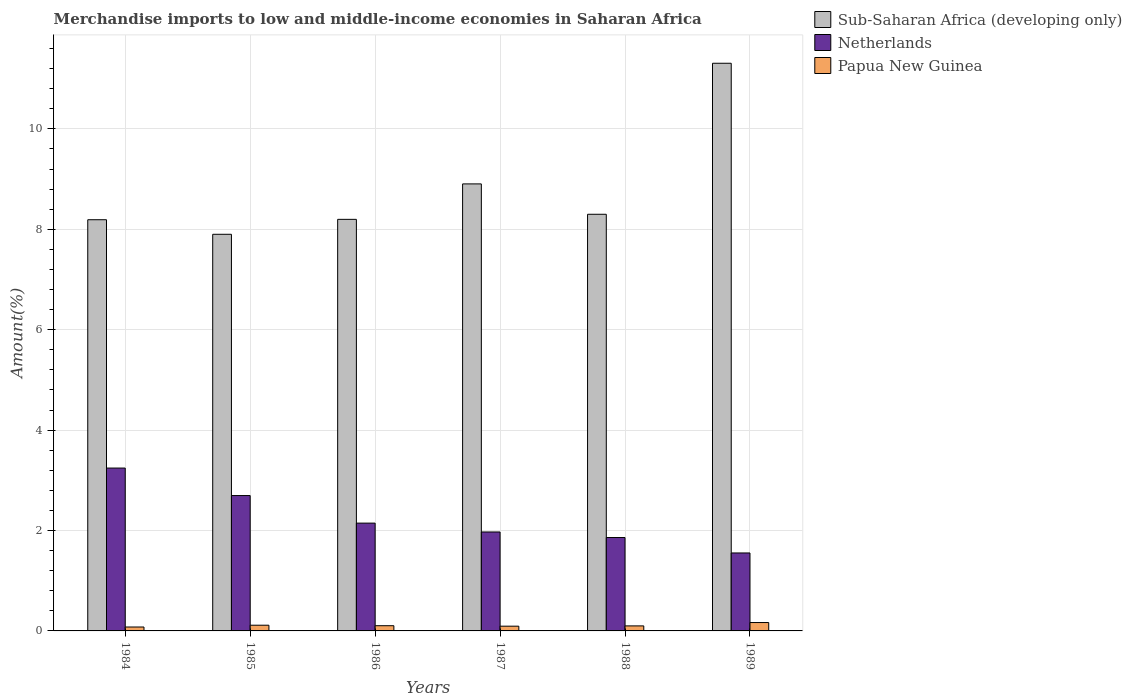How many different coloured bars are there?
Provide a succinct answer. 3. Are the number of bars per tick equal to the number of legend labels?
Keep it short and to the point. Yes. Are the number of bars on each tick of the X-axis equal?
Ensure brevity in your answer.  Yes. How many bars are there on the 2nd tick from the left?
Provide a succinct answer. 3. What is the label of the 5th group of bars from the left?
Your response must be concise. 1988. What is the percentage of amount earned from merchandise imports in Netherlands in 1987?
Make the answer very short. 1.97. Across all years, what is the maximum percentage of amount earned from merchandise imports in Netherlands?
Provide a short and direct response. 3.24. Across all years, what is the minimum percentage of amount earned from merchandise imports in Papua New Guinea?
Make the answer very short. 0.08. In which year was the percentage of amount earned from merchandise imports in Sub-Saharan Africa (developing only) maximum?
Ensure brevity in your answer.  1989. In which year was the percentage of amount earned from merchandise imports in Sub-Saharan Africa (developing only) minimum?
Keep it short and to the point. 1985. What is the total percentage of amount earned from merchandise imports in Netherlands in the graph?
Keep it short and to the point. 13.47. What is the difference between the percentage of amount earned from merchandise imports in Sub-Saharan Africa (developing only) in 1984 and that in 1986?
Give a very brief answer. -0.01. What is the difference between the percentage of amount earned from merchandise imports in Netherlands in 1988 and the percentage of amount earned from merchandise imports in Sub-Saharan Africa (developing only) in 1989?
Your answer should be compact. -9.45. What is the average percentage of amount earned from merchandise imports in Sub-Saharan Africa (developing only) per year?
Provide a short and direct response. 8.8. In the year 1987, what is the difference between the percentage of amount earned from merchandise imports in Papua New Guinea and percentage of amount earned from merchandise imports in Netherlands?
Your response must be concise. -1.88. What is the ratio of the percentage of amount earned from merchandise imports in Netherlands in 1987 to that in 1989?
Give a very brief answer. 1.27. What is the difference between the highest and the second highest percentage of amount earned from merchandise imports in Netherlands?
Offer a very short reply. 0.55. What is the difference between the highest and the lowest percentage of amount earned from merchandise imports in Sub-Saharan Africa (developing only)?
Make the answer very short. 3.41. What does the 3rd bar from the left in 1989 represents?
Your answer should be compact. Papua New Guinea. What does the 2nd bar from the right in 1988 represents?
Ensure brevity in your answer.  Netherlands. Is it the case that in every year, the sum of the percentage of amount earned from merchandise imports in Papua New Guinea and percentage of amount earned from merchandise imports in Sub-Saharan Africa (developing only) is greater than the percentage of amount earned from merchandise imports in Netherlands?
Make the answer very short. Yes. How many bars are there?
Your answer should be compact. 18. Are all the bars in the graph horizontal?
Keep it short and to the point. No. What is the difference between two consecutive major ticks on the Y-axis?
Your response must be concise. 2. Are the values on the major ticks of Y-axis written in scientific E-notation?
Give a very brief answer. No. Does the graph contain any zero values?
Ensure brevity in your answer.  No. Does the graph contain grids?
Ensure brevity in your answer.  Yes. Where does the legend appear in the graph?
Your answer should be compact. Top right. How many legend labels are there?
Your response must be concise. 3. What is the title of the graph?
Provide a succinct answer. Merchandise imports to low and middle-income economies in Saharan Africa. What is the label or title of the Y-axis?
Provide a succinct answer. Amount(%). What is the Amount(%) in Sub-Saharan Africa (developing only) in 1984?
Your answer should be compact. 8.19. What is the Amount(%) in Netherlands in 1984?
Provide a succinct answer. 3.24. What is the Amount(%) in Papua New Guinea in 1984?
Ensure brevity in your answer.  0.08. What is the Amount(%) in Sub-Saharan Africa (developing only) in 1985?
Your answer should be compact. 7.9. What is the Amount(%) of Netherlands in 1985?
Provide a succinct answer. 2.7. What is the Amount(%) of Papua New Guinea in 1985?
Ensure brevity in your answer.  0.11. What is the Amount(%) of Sub-Saharan Africa (developing only) in 1986?
Make the answer very short. 8.2. What is the Amount(%) in Netherlands in 1986?
Offer a terse response. 2.15. What is the Amount(%) in Papua New Guinea in 1986?
Your answer should be compact. 0.1. What is the Amount(%) of Sub-Saharan Africa (developing only) in 1987?
Your response must be concise. 8.9. What is the Amount(%) in Netherlands in 1987?
Your answer should be compact. 1.97. What is the Amount(%) of Papua New Guinea in 1987?
Your response must be concise. 0.09. What is the Amount(%) of Sub-Saharan Africa (developing only) in 1988?
Give a very brief answer. 8.3. What is the Amount(%) in Netherlands in 1988?
Keep it short and to the point. 1.86. What is the Amount(%) in Papua New Guinea in 1988?
Offer a very short reply. 0.1. What is the Amount(%) in Sub-Saharan Africa (developing only) in 1989?
Make the answer very short. 11.31. What is the Amount(%) in Netherlands in 1989?
Ensure brevity in your answer.  1.55. What is the Amount(%) in Papua New Guinea in 1989?
Give a very brief answer. 0.17. Across all years, what is the maximum Amount(%) of Sub-Saharan Africa (developing only)?
Provide a succinct answer. 11.31. Across all years, what is the maximum Amount(%) in Netherlands?
Offer a terse response. 3.24. Across all years, what is the maximum Amount(%) of Papua New Guinea?
Your answer should be compact. 0.17. Across all years, what is the minimum Amount(%) in Sub-Saharan Africa (developing only)?
Keep it short and to the point. 7.9. Across all years, what is the minimum Amount(%) in Netherlands?
Keep it short and to the point. 1.55. Across all years, what is the minimum Amount(%) of Papua New Guinea?
Your response must be concise. 0.08. What is the total Amount(%) of Sub-Saharan Africa (developing only) in the graph?
Ensure brevity in your answer.  52.8. What is the total Amount(%) of Netherlands in the graph?
Make the answer very short. 13.47. What is the total Amount(%) in Papua New Guinea in the graph?
Your answer should be compact. 0.66. What is the difference between the Amount(%) in Sub-Saharan Africa (developing only) in 1984 and that in 1985?
Offer a very short reply. 0.29. What is the difference between the Amount(%) of Netherlands in 1984 and that in 1985?
Keep it short and to the point. 0.55. What is the difference between the Amount(%) of Papua New Guinea in 1984 and that in 1985?
Offer a very short reply. -0.04. What is the difference between the Amount(%) of Sub-Saharan Africa (developing only) in 1984 and that in 1986?
Your answer should be very brief. -0.01. What is the difference between the Amount(%) in Netherlands in 1984 and that in 1986?
Your answer should be very brief. 1.1. What is the difference between the Amount(%) of Papua New Guinea in 1984 and that in 1986?
Give a very brief answer. -0.03. What is the difference between the Amount(%) in Sub-Saharan Africa (developing only) in 1984 and that in 1987?
Your answer should be compact. -0.71. What is the difference between the Amount(%) of Netherlands in 1984 and that in 1987?
Your response must be concise. 1.27. What is the difference between the Amount(%) of Papua New Guinea in 1984 and that in 1987?
Provide a succinct answer. -0.02. What is the difference between the Amount(%) of Sub-Saharan Africa (developing only) in 1984 and that in 1988?
Offer a very short reply. -0.11. What is the difference between the Amount(%) in Netherlands in 1984 and that in 1988?
Your answer should be compact. 1.38. What is the difference between the Amount(%) of Papua New Guinea in 1984 and that in 1988?
Provide a succinct answer. -0.02. What is the difference between the Amount(%) in Sub-Saharan Africa (developing only) in 1984 and that in 1989?
Provide a succinct answer. -3.12. What is the difference between the Amount(%) of Netherlands in 1984 and that in 1989?
Make the answer very short. 1.69. What is the difference between the Amount(%) in Papua New Guinea in 1984 and that in 1989?
Your answer should be very brief. -0.09. What is the difference between the Amount(%) in Sub-Saharan Africa (developing only) in 1985 and that in 1986?
Keep it short and to the point. -0.3. What is the difference between the Amount(%) of Netherlands in 1985 and that in 1986?
Your response must be concise. 0.55. What is the difference between the Amount(%) in Sub-Saharan Africa (developing only) in 1985 and that in 1987?
Give a very brief answer. -1. What is the difference between the Amount(%) in Netherlands in 1985 and that in 1987?
Offer a terse response. 0.73. What is the difference between the Amount(%) of Papua New Guinea in 1985 and that in 1987?
Offer a very short reply. 0.02. What is the difference between the Amount(%) in Sub-Saharan Africa (developing only) in 1985 and that in 1988?
Make the answer very short. -0.4. What is the difference between the Amount(%) of Netherlands in 1985 and that in 1988?
Ensure brevity in your answer.  0.84. What is the difference between the Amount(%) in Papua New Guinea in 1985 and that in 1988?
Keep it short and to the point. 0.01. What is the difference between the Amount(%) of Sub-Saharan Africa (developing only) in 1985 and that in 1989?
Offer a terse response. -3.41. What is the difference between the Amount(%) of Netherlands in 1985 and that in 1989?
Make the answer very short. 1.14. What is the difference between the Amount(%) of Papua New Guinea in 1985 and that in 1989?
Make the answer very short. -0.05. What is the difference between the Amount(%) of Sub-Saharan Africa (developing only) in 1986 and that in 1987?
Keep it short and to the point. -0.71. What is the difference between the Amount(%) of Netherlands in 1986 and that in 1987?
Offer a very short reply. 0.18. What is the difference between the Amount(%) of Papua New Guinea in 1986 and that in 1987?
Offer a terse response. 0.01. What is the difference between the Amount(%) of Sub-Saharan Africa (developing only) in 1986 and that in 1988?
Make the answer very short. -0.1. What is the difference between the Amount(%) in Netherlands in 1986 and that in 1988?
Give a very brief answer. 0.29. What is the difference between the Amount(%) in Papua New Guinea in 1986 and that in 1988?
Your response must be concise. 0. What is the difference between the Amount(%) in Sub-Saharan Africa (developing only) in 1986 and that in 1989?
Make the answer very short. -3.11. What is the difference between the Amount(%) of Netherlands in 1986 and that in 1989?
Provide a short and direct response. 0.59. What is the difference between the Amount(%) in Papua New Guinea in 1986 and that in 1989?
Give a very brief answer. -0.06. What is the difference between the Amount(%) of Sub-Saharan Africa (developing only) in 1987 and that in 1988?
Offer a terse response. 0.6. What is the difference between the Amount(%) of Netherlands in 1987 and that in 1988?
Your answer should be very brief. 0.11. What is the difference between the Amount(%) in Papua New Guinea in 1987 and that in 1988?
Your answer should be compact. -0.01. What is the difference between the Amount(%) of Sub-Saharan Africa (developing only) in 1987 and that in 1989?
Offer a very short reply. -2.4. What is the difference between the Amount(%) in Netherlands in 1987 and that in 1989?
Ensure brevity in your answer.  0.42. What is the difference between the Amount(%) of Papua New Guinea in 1987 and that in 1989?
Give a very brief answer. -0.07. What is the difference between the Amount(%) of Sub-Saharan Africa (developing only) in 1988 and that in 1989?
Keep it short and to the point. -3.01. What is the difference between the Amount(%) of Netherlands in 1988 and that in 1989?
Make the answer very short. 0.31. What is the difference between the Amount(%) of Papua New Guinea in 1988 and that in 1989?
Ensure brevity in your answer.  -0.07. What is the difference between the Amount(%) in Sub-Saharan Africa (developing only) in 1984 and the Amount(%) in Netherlands in 1985?
Offer a terse response. 5.49. What is the difference between the Amount(%) in Sub-Saharan Africa (developing only) in 1984 and the Amount(%) in Papua New Guinea in 1985?
Offer a terse response. 8.08. What is the difference between the Amount(%) in Netherlands in 1984 and the Amount(%) in Papua New Guinea in 1985?
Provide a short and direct response. 3.13. What is the difference between the Amount(%) of Sub-Saharan Africa (developing only) in 1984 and the Amount(%) of Netherlands in 1986?
Provide a succinct answer. 6.04. What is the difference between the Amount(%) in Sub-Saharan Africa (developing only) in 1984 and the Amount(%) in Papua New Guinea in 1986?
Keep it short and to the point. 8.09. What is the difference between the Amount(%) in Netherlands in 1984 and the Amount(%) in Papua New Guinea in 1986?
Your response must be concise. 3.14. What is the difference between the Amount(%) of Sub-Saharan Africa (developing only) in 1984 and the Amount(%) of Netherlands in 1987?
Give a very brief answer. 6.22. What is the difference between the Amount(%) in Sub-Saharan Africa (developing only) in 1984 and the Amount(%) in Papua New Guinea in 1987?
Offer a very short reply. 8.1. What is the difference between the Amount(%) of Netherlands in 1984 and the Amount(%) of Papua New Guinea in 1987?
Give a very brief answer. 3.15. What is the difference between the Amount(%) of Sub-Saharan Africa (developing only) in 1984 and the Amount(%) of Netherlands in 1988?
Keep it short and to the point. 6.33. What is the difference between the Amount(%) of Sub-Saharan Africa (developing only) in 1984 and the Amount(%) of Papua New Guinea in 1988?
Offer a terse response. 8.09. What is the difference between the Amount(%) of Netherlands in 1984 and the Amount(%) of Papua New Guinea in 1988?
Keep it short and to the point. 3.14. What is the difference between the Amount(%) in Sub-Saharan Africa (developing only) in 1984 and the Amount(%) in Netherlands in 1989?
Provide a short and direct response. 6.64. What is the difference between the Amount(%) of Sub-Saharan Africa (developing only) in 1984 and the Amount(%) of Papua New Guinea in 1989?
Give a very brief answer. 8.02. What is the difference between the Amount(%) of Netherlands in 1984 and the Amount(%) of Papua New Guinea in 1989?
Keep it short and to the point. 3.08. What is the difference between the Amount(%) in Sub-Saharan Africa (developing only) in 1985 and the Amount(%) in Netherlands in 1986?
Your answer should be very brief. 5.75. What is the difference between the Amount(%) in Sub-Saharan Africa (developing only) in 1985 and the Amount(%) in Papua New Guinea in 1986?
Your answer should be very brief. 7.8. What is the difference between the Amount(%) in Netherlands in 1985 and the Amount(%) in Papua New Guinea in 1986?
Offer a very short reply. 2.59. What is the difference between the Amount(%) in Sub-Saharan Africa (developing only) in 1985 and the Amount(%) in Netherlands in 1987?
Your response must be concise. 5.93. What is the difference between the Amount(%) of Sub-Saharan Africa (developing only) in 1985 and the Amount(%) of Papua New Guinea in 1987?
Provide a short and direct response. 7.81. What is the difference between the Amount(%) in Netherlands in 1985 and the Amount(%) in Papua New Guinea in 1987?
Offer a very short reply. 2.6. What is the difference between the Amount(%) of Sub-Saharan Africa (developing only) in 1985 and the Amount(%) of Netherlands in 1988?
Your response must be concise. 6.04. What is the difference between the Amount(%) of Sub-Saharan Africa (developing only) in 1985 and the Amount(%) of Papua New Guinea in 1988?
Give a very brief answer. 7.8. What is the difference between the Amount(%) in Netherlands in 1985 and the Amount(%) in Papua New Guinea in 1988?
Your response must be concise. 2.6. What is the difference between the Amount(%) of Sub-Saharan Africa (developing only) in 1985 and the Amount(%) of Netherlands in 1989?
Give a very brief answer. 6.35. What is the difference between the Amount(%) in Sub-Saharan Africa (developing only) in 1985 and the Amount(%) in Papua New Guinea in 1989?
Keep it short and to the point. 7.73. What is the difference between the Amount(%) of Netherlands in 1985 and the Amount(%) of Papua New Guinea in 1989?
Your response must be concise. 2.53. What is the difference between the Amount(%) in Sub-Saharan Africa (developing only) in 1986 and the Amount(%) in Netherlands in 1987?
Make the answer very short. 6.23. What is the difference between the Amount(%) of Sub-Saharan Africa (developing only) in 1986 and the Amount(%) of Papua New Guinea in 1987?
Offer a very short reply. 8.1. What is the difference between the Amount(%) in Netherlands in 1986 and the Amount(%) in Papua New Guinea in 1987?
Your answer should be very brief. 2.05. What is the difference between the Amount(%) in Sub-Saharan Africa (developing only) in 1986 and the Amount(%) in Netherlands in 1988?
Provide a succinct answer. 6.34. What is the difference between the Amount(%) in Sub-Saharan Africa (developing only) in 1986 and the Amount(%) in Papua New Guinea in 1988?
Your answer should be very brief. 8.1. What is the difference between the Amount(%) in Netherlands in 1986 and the Amount(%) in Papua New Guinea in 1988?
Make the answer very short. 2.05. What is the difference between the Amount(%) of Sub-Saharan Africa (developing only) in 1986 and the Amount(%) of Netherlands in 1989?
Offer a terse response. 6.65. What is the difference between the Amount(%) of Sub-Saharan Africa (developing only) in 1986 and the Amount(%) of Papua New Guinea in 1989?
Provide a short and direct response. 8.03. What is the difference between the Amount(%) of Netherlands in 1986 and the Amount(%) of Papua New Guinea in 1989?
Keep it short and to the point. 1.98. What is the difference between the Amount(%) in Sub-Saharan Africa (developing only) in 1987 and the Amount(%) in Netherlands in 1988?
Ensure brevity in your answer.  7.04. What is the difference between the Amount(%) in Sub-Saharan Africa (developing only) in 1987 and the Amount(%) in Papua New Guinea in 1988?
Ensure brevity in your answer.  8.8. What is the difference between the Amount(%) of Netherlands in 1987 and the Amount(%) of Papua New Guinea in 1988?
Give a very brief answer. 1.87. What is the difference between the Amount(%) in Sub-Saharan Africa (developing only) in 1987 and the Amount(%) in Netherlands in 1989?
Your response must be concise. 7.35. What is the difference between the Amount(%) in Sub-Saharan Africa (developing only) in 1987 and the Amount(%) in Papua New Guinea in 1989?
Provide a short and direct response. 8.74. What is the difference between the Amount(%) in Netherlands in 1987 and the Amount(%) in Papua New Guinea in 1989?
Give a very brief answer. 1.8. What is the difference between the Amount(%) in Sub-Saharan Africa (developing only) in 1988 and the Amount(%) in Netherlands in 1989?
Your answer should be very brief. 6.75. What is the difference between the Amount(%) of Sub-Saharan Africa (developing only) in 1988 and the Amount(%) of Papua New Guinea in 1989?
Provide a short and direct response. 8.13. What is the difference between the Amount(%) of Netherlands in 1988 and the Amount(%) of Papua New Guinea in 1989?
Provide a short and direct response. 1.69. What is the average Amount(%) of Sub-Saharan Africa (developing only) per year?
Keep it short and to the point. 8.8. What is the average Amount(%) in Netherlands per year?
Make the answer very short. 2.25. What is the average Amount(%) in Papua New Guinea per year?
Provide a short and direct response. 0.11. In the year 1984, what is the difference between the Amount(%) in Sub-Saharan Africa (developing only) and Amount(%) in Netherlands?
Your answer should be very brief. 4.95. In the year 1984, what is the difference between the Amount(%) of Sub-Saharan Africa (developing only) and Amount(%) of Papua New Guinea?
Provide a short and direct response. 8.11. In the year 1984, what is the difference between the Amount(%) of Netherlands and Amount(%) of Papua New Guinea?
Provide a short and direct response. 3.17. In the year 1985, what is the difference between the Amount(%) in Sub-Saharan Africa (developing only) and Amount(%) in Netherlands?
Offer a terse response. 5.2. In the year 1985, what is the difference between the Amount(%) of Sub-Saharan Africa (developing only) and Amount(%) of Papua New Guinea?
Your response must be concise. 7.79. In the year 1985, what is the difference between the Amount(%) in Netherlands and Amount(%) in Papua New Guinea?
Offer a terse response. 2.58. In the year 1986, what is the difference between the Amount(%) in Sub-Saharan Africa (developing only) and Amount(%) in Netherlands?
Your answer should be compact. 6.05. In the year 1986, what is the difference between the Amount(%) in Sub-Saharan Africa (developing only) and Amount(%) in Papua New Guinea?
Your answer should be compact. 8.09. In the year 1986, what is the difference between the Amount(%) in Netherlands and Amount(%) in Papua New Guinea?
Make the answer very short. 2.04. In the year 1987, what is the difference between the Amount(%) of Sub-Saharan Africa (developing only) and Amount(%) of Netherlands?
Ensure brevity in your answer.  6.93. In the year 1987, what is the difference between the Amount(%) in Sub-Saharan Africa (developing only) and Amount(%) in Papua New Guinea?
Offer a very short reply. 8.81. In the year 1987, what is the difference between the Amount(%) in Netherlands and Amount(%) in Papua New Guinea?
Make the answer very short. 1.88. In the year 1988, what is the difference between the Amount(%) of Sub-Saharan Africa (developing only) and Amount(%) of Netherlands?
Provide a short and direct response. 6.44. In the year 1988, what is the difference between the Amount(%) in Sub-Saharan Africa (developing only) and Amount(%) in Papua New Guinea?
Your answer should be very brief. 8.2. In the year 1988, what is the difference between the Amount(%) in Netherlands and Amount(%) in Papua New Guinea?
Your answer should be compact. 1.76. In the year 1989, what is the difference between the Amount(%) in Sub-Saharan Africa (developing only) and Amount(%) in Netherlands?
Provide a short and direct response. 9.75. In the year 1989, what is the difference between the Amount(%) in Sub-Saharan Africa (developing only) and Amount(%) in Papua New Guinea?
Offer a very short reply. 11.14. In the year 1989, what is the difference between the Amount(%) of Netherlands and Amount(%) of Papua New Guinea?
Provide a short and direct response. 1.39. What is the ratio of the Amount(%) in Sub-Saharan Africa (developing only) in 1984 to that in 1985?
Your response must be concise. 1.04. What is the ratio of the Amount(%) of Netherlands in 1984 to that in 1985?
Offer a terse response. 1.2. What is the ratio of the Amount(%) of Papua New Guinea in 1984 to that in 1985?
Give a very brief answer. 0.69. What is the ratio of the Amount(%) of Netherlands in 1984 to that in 1986?
Your response must be concise. 1.51. What is the ratio of the Amount(%) in Papua New Guinea in 1984 to that in 1986?
Make the answer very short. 0.75. What is the ratio of the Amount(%) of Sub-Saharan Africa (developing only) in 1984 to that in 1987?
Give a very brief answer. 0.92. What is the ratio of the Amount(%) of Netherlands in 1984 to that in 1987?
Provide a short and direct response. 1.65. What is the ratio of the Amount(%) in Papua New Guinea in 1984 to that in 1987?
Provide a succinct answer. 0.82. What is the ratio of the Amount(%) in Sub-Saharan Africa (developing only) in 1984 to that in 1988?
Offer a terse response. 0.99. What is the ratio of the Amount(%) in Netherlands in 1984 to that in 1988?
Your response must be concise. 1.74. What is the ratio of the Amount(%) of Papua New Guinea in 1984 to that in 1988?
Provide a succinct answer. 0.78. What is the ratio of the Amount(%) of Sub-Saharan Africa (developing only) in 1984 to that in 1989?
Offer a very short reply. 0.72. What is the ratio of the Amount(%) in Netherlands in 1984 to that in 1989?
Make the answer very short. 2.09. What is the ratio of the Amount(%) in Papua New Guinea in 1984 to that in 1989?
Ensure brevity in your answer.  0.47. What is the ratio of the Amount(%) in Sub-Saharan Africa (developing only) in 1985 to that in 1986?
Your answer should be compact. 0.96. What is the ratio of the Amount(%) in Netherlands in 1985 to that in 1986?
Make the answer very short. 1.26. What is the ratio of the Amount(%) of Papua New Guinea in 1985 to that in 1986?
Your answer should be very brief. 1.1. What is the ratio of the Amount(%) of Sub-Saharan Africa (developing only) in 1985 to that in 1987?
Offer a terse response. 0.89. What is the ratio of the Amount(%) of Netherlands in 1985 to that in 1987?
Your answer should be very brief. 1.37. What is the ratio of the Amount(%) in Papua New Guinea in 1985 to that in 1987?
Ensure brevity in your answer.  1.2. What is the ratio of the Amount(%) in Sub-Saharan Africa (developing only) in 1985 to that in 1988?
Provide a succinct answer. 0.95. What is the ratio of the Amount(%) of Netherlands in 1985 to that in 1988?
Ensure brevity in your answer.  1.45. What is the ratio of the Amount(%) of Papua New Guinea in 1985 to that in 1988?
Your response must be concise. 1.14. What is the ratio of the Amount(%) of Sub-Saharan Africa (developing only) in 1985 to that in 1989?
Your answer should be very brief. 0.7. What is the ratio of the Amount(%) of Netherlands in 1985 to that in 1989?
Keep it short and to the point. 1.74. What is the ratio of the Amount(%) in Papua New Guinea in 1985 to that in 1989?
Provide a succinct answer. 0.68. What is the ratio of the Amount(%) in Sub-Saharan Africa (developing only) in 1986 to that in 1987?
Ensure brevity in your answer.  0.92. What is the ratio of the Amount(%) of Netherlands in 1986 to that in 1987?
Offer a very short reply. 1.09. What is the ratio of the Amount(%) in Papua New Guinea in 1986 to that in 1987?
Your answer should be compact. 1.1. What is the ratio of the Amount(%) in Sub-Saharan Africa (developing only) in 1986 to that in 1988?
Offer a terse response. 0.99. What is the ratio of the Amount(%) in Netherlands in 1986 to that in 1988?
Provide a short and direct response. 1.15. What is the ratio of the Amount(%) in Papua New Guinea in 1986 to that in 1988?
Your answer should be very brief. 1.04. What is the ratio of the Amount(%) of Sub-Saharan Africa (developing only) in 1986 to that in 1989?
Offer a very short reply. 0.72. What is the ratio of the Amount(%) of Netherlands in 1986 to that in 1989?
Your answer should be very brief. 1.38. What is the ratio of the Amount(%) in Papua New Guinea in 1986 to that in 1989?
Keep it short and to the point. 0.62. What is the ratio of the Amount(%) in Sub-Saharan Africa (developing only) in 1987 to that in 1988?
Provide a succinct answer. 1.07. What is the ratio of the Amount(%) of Netherlands in 1987 to that in 1988?
Offer a very short reply. 1.06. What is the ratio of the Amount(%) of Papua New Guinea in 1987 to that in 1988?
Make the answer very short. 0.94. What is the ratio of the Amount(%) in Sub-Saharan Africa (developing only) in 1987 to that in 1989?
Your response must be concise. 0.79. What is the ratio of the Amount(%) of Netherlands in 1987 to that in 1989?
Your response must be concise. 1.27. What is the ratio of the Amount(%) of Papua New Guinea in 1987 to that in 1989?
Provide a short and direct response. 0.57. What is the ratio of the Amount(%) in Sub-Saharan Africa (developing only) in 1988 to that in 1989?
Your answer should be very brief. 0.73. What is the ratio of the Amount(%) in Netherlands in 1988 to that in 1989?
Give a very brief answer. 1.2. What is the ratio of the Amount(%) of Papua New Guinea in 1988 to that in 1989?
Give a very brief answer. 0.6. What is the difference between the highest and the second highest Amount(%) of Sub-Saharan Africa (developing only)?
Keep it short and to the point. 2.4. What is the difference between the highest and the second highest Amount(%) of Netherlands?
Ensure brevity in your answer.  0.55. What is the difference between the highest and the second highest Amount(%) of Papua New Guinea?
Offer a very short reply. 0.05. What is the difference between the highest and the lowest Amount(%) of Sub-Saharan Africa (developing only)?
Ensure brevity in your answer.  3.41. What is the difference between the highest and the lowest Amount(%) in Netherlands?
Your answer should be very brief. 1.69. What is the difference between the highest and the lowest Amount(%) of Papua New Guinea?
Give a very brief answer. 0.09. 